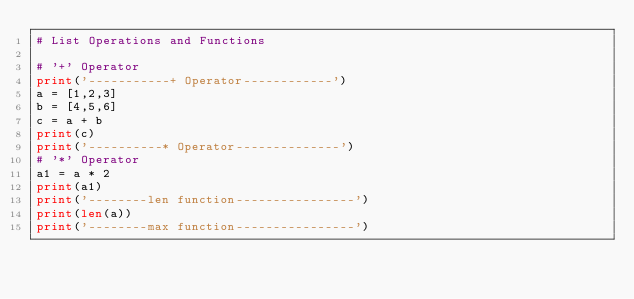<code> <loc_0><loc_0><loc_500><loc_500><_Python_># List Operations and Functions

# '+' Operator
print('-----------+ Operator------------')
a = [1,2,3]
b = [4,5,6]
c = a + b
print(c)
print('----------* Operator--------------')
# '*' Operator
a1 = a * 2
print(a1)
print('--------len function----------------')
print(len(a))
print('--------max function----------------')</code> 